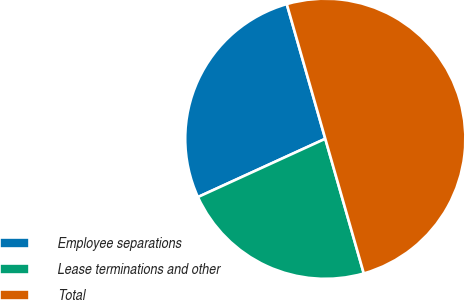Convert chart. <chart><loc_0><loc_0><loc_500><loc_500><pie_chart><fcel>Employee separations<fcel>Lease terminations and other<fcel>Total<nl><fcel>27.4%<fcel>22.6%<fcel>50.0%<nl></chart> 